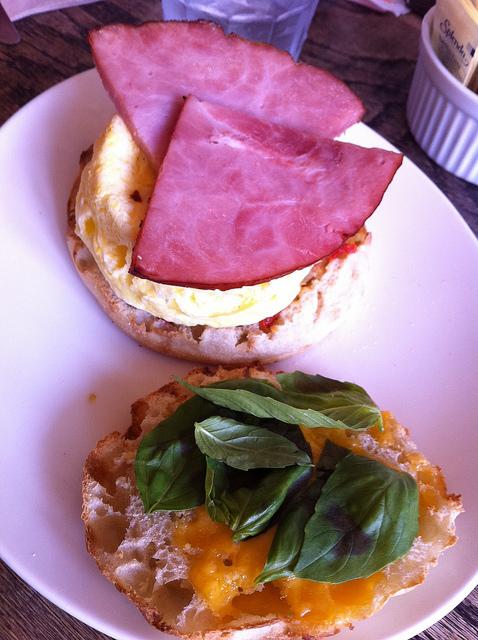How many pieces of ham are on the plate?
Write a very short answer. 2. What is the color of the plate?
Answer briefly. White. Is this a restaurant?
Short answer required. Yes. 